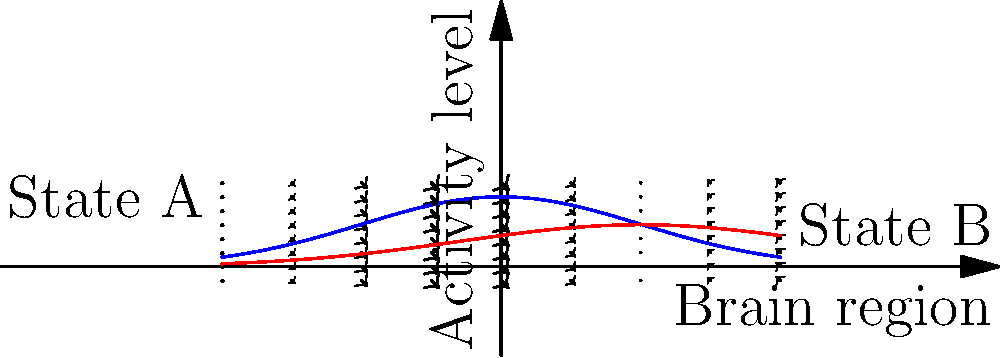The vector field shown represents the difference in brain activity patterns between two mental states, A and B. The x-axis represents different brain regions, and the y-axis represents the activity level. The blue curve represents the activity pattern in State A, while the red curve represents State B. Given this information, what does the direction of the vectors indicate about the transition between these two mental states? To answer this question, let's analyze the vector field step by step:

1. The vector field is created by subtracting the activity level of State B from State A at each point.

2. The x-component of each vector represents the difference in activity between State A and State B for a given brain region:
   $dx = k(f(x) - g(x))$, where $k$ is a scaling factor, $f(x)$ is the activity level for State A, and $g(x)$ is the activity level for State B.

3. The y-component of each vector represents the tendency of the activity to move towards the other state:
   $dy = k(g(x) - f(x))$, which is the negative of the x-component.

4. Observing the vector field:
   - On the left side (negative x), vectors point upward and to the right.
   - On the right side (positive x), vectors point downward and to the left.

5. This pattern indicates that:
   - In regions where State A has higher activity (left side), the vectors point towards State B.
   - In regions where State B has higher activity (right side), the vectors point towards State A.

6. The direction of the vectors shows the "flow" or tendency of brain activity when transitioning between these two states.

Therefore, the direction of the vectors indicates the path of least resistance for transitioning between State A and State B, showing how brain activity patterns would change during this transition.
Answer: The vector direction indicates the path of transition between States A and B, showing how brain activity patterns change across different regions. 